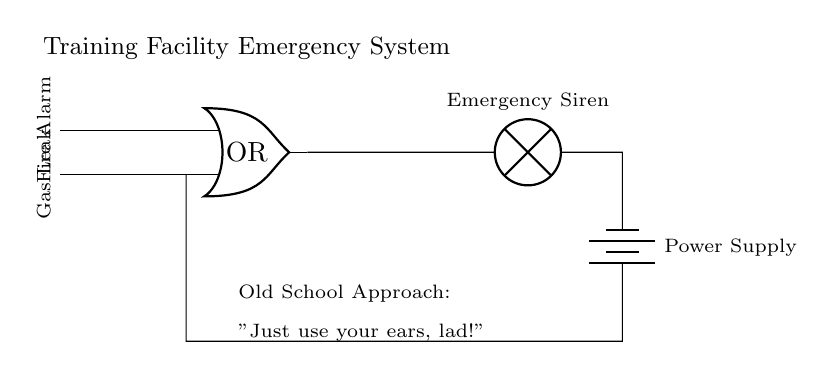What type of logic gate is represented in this circuit? The circuit diagram clearly shows an OR gate, which is indicated by the symbol labeled "OR" at the center of the circuit.
Answer: OR How many inputs does the OR gate have in this circuit? The OR gate has two inputs, which are labeled "Fire Alarm" and "Gas Leak" on the left side of the diagram.
Answer: 2 What is the output component connected to the OR gate? The output of the OR gate connects to an "Emergency Siren," which is located to the right of the gate and is part of the alarm system.
Answer: Emergency Siren What triggers the emergency alarm system in this circuit? The emergency alarm is triggered by either the "Fire Alarm" or "Gas Leak" inputs being activated, making this a critical safety feature for the training facility.
Answer: Either input What is the power source used in this circuit? The power supply for the circuit is represented by a "Battery," which is indicated after the emergency siren in the circuit diagram.
Answer: Battery In the diagram, what approach does the text suggest as an "Old School Approach"? The old school approach is humorously mentioned as "Just use your ears, lad!" indicating a more traditional method of alerting to emergencies compared to the current system.
Answer: Just use your ears, lad! How does the OR gate affect the flow of electricity when activated? When either of the inputs (Fire Alarm or Gas Leak) is activated, the OR gate allows electricity to flow through to the output (Emergency Siren), making the alarm sound.
Answer: Allows flow 